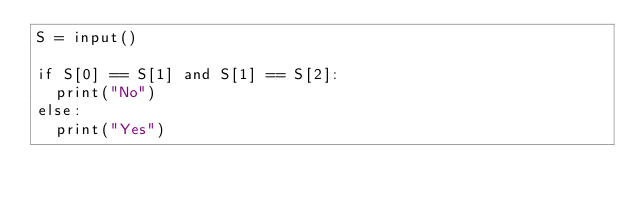<code> <loc_0><loc_0><loc_500><loc_500><_Python_>S = input()

if S[0] == S[1] and S[1] == S[2]:
  print("No")
else:
  print("Yes")</code> 